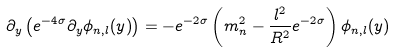<formula> <loc_0><loc_0><loc_500><loc_500>\partial _ { y } \left ( e ^ { - 4 \sigma } \partial _ { y } \phi _ { n , l } ( y ) \right ) = - e ^ { - 2 \sigma } \left ( m _ { n } ^ { 2 } - \frac { l ^ { 2 } } { R ^ { 2 } } e ^ { - 2 \sigma } \right ) \phi _ { n , l } ( y )</formula> 